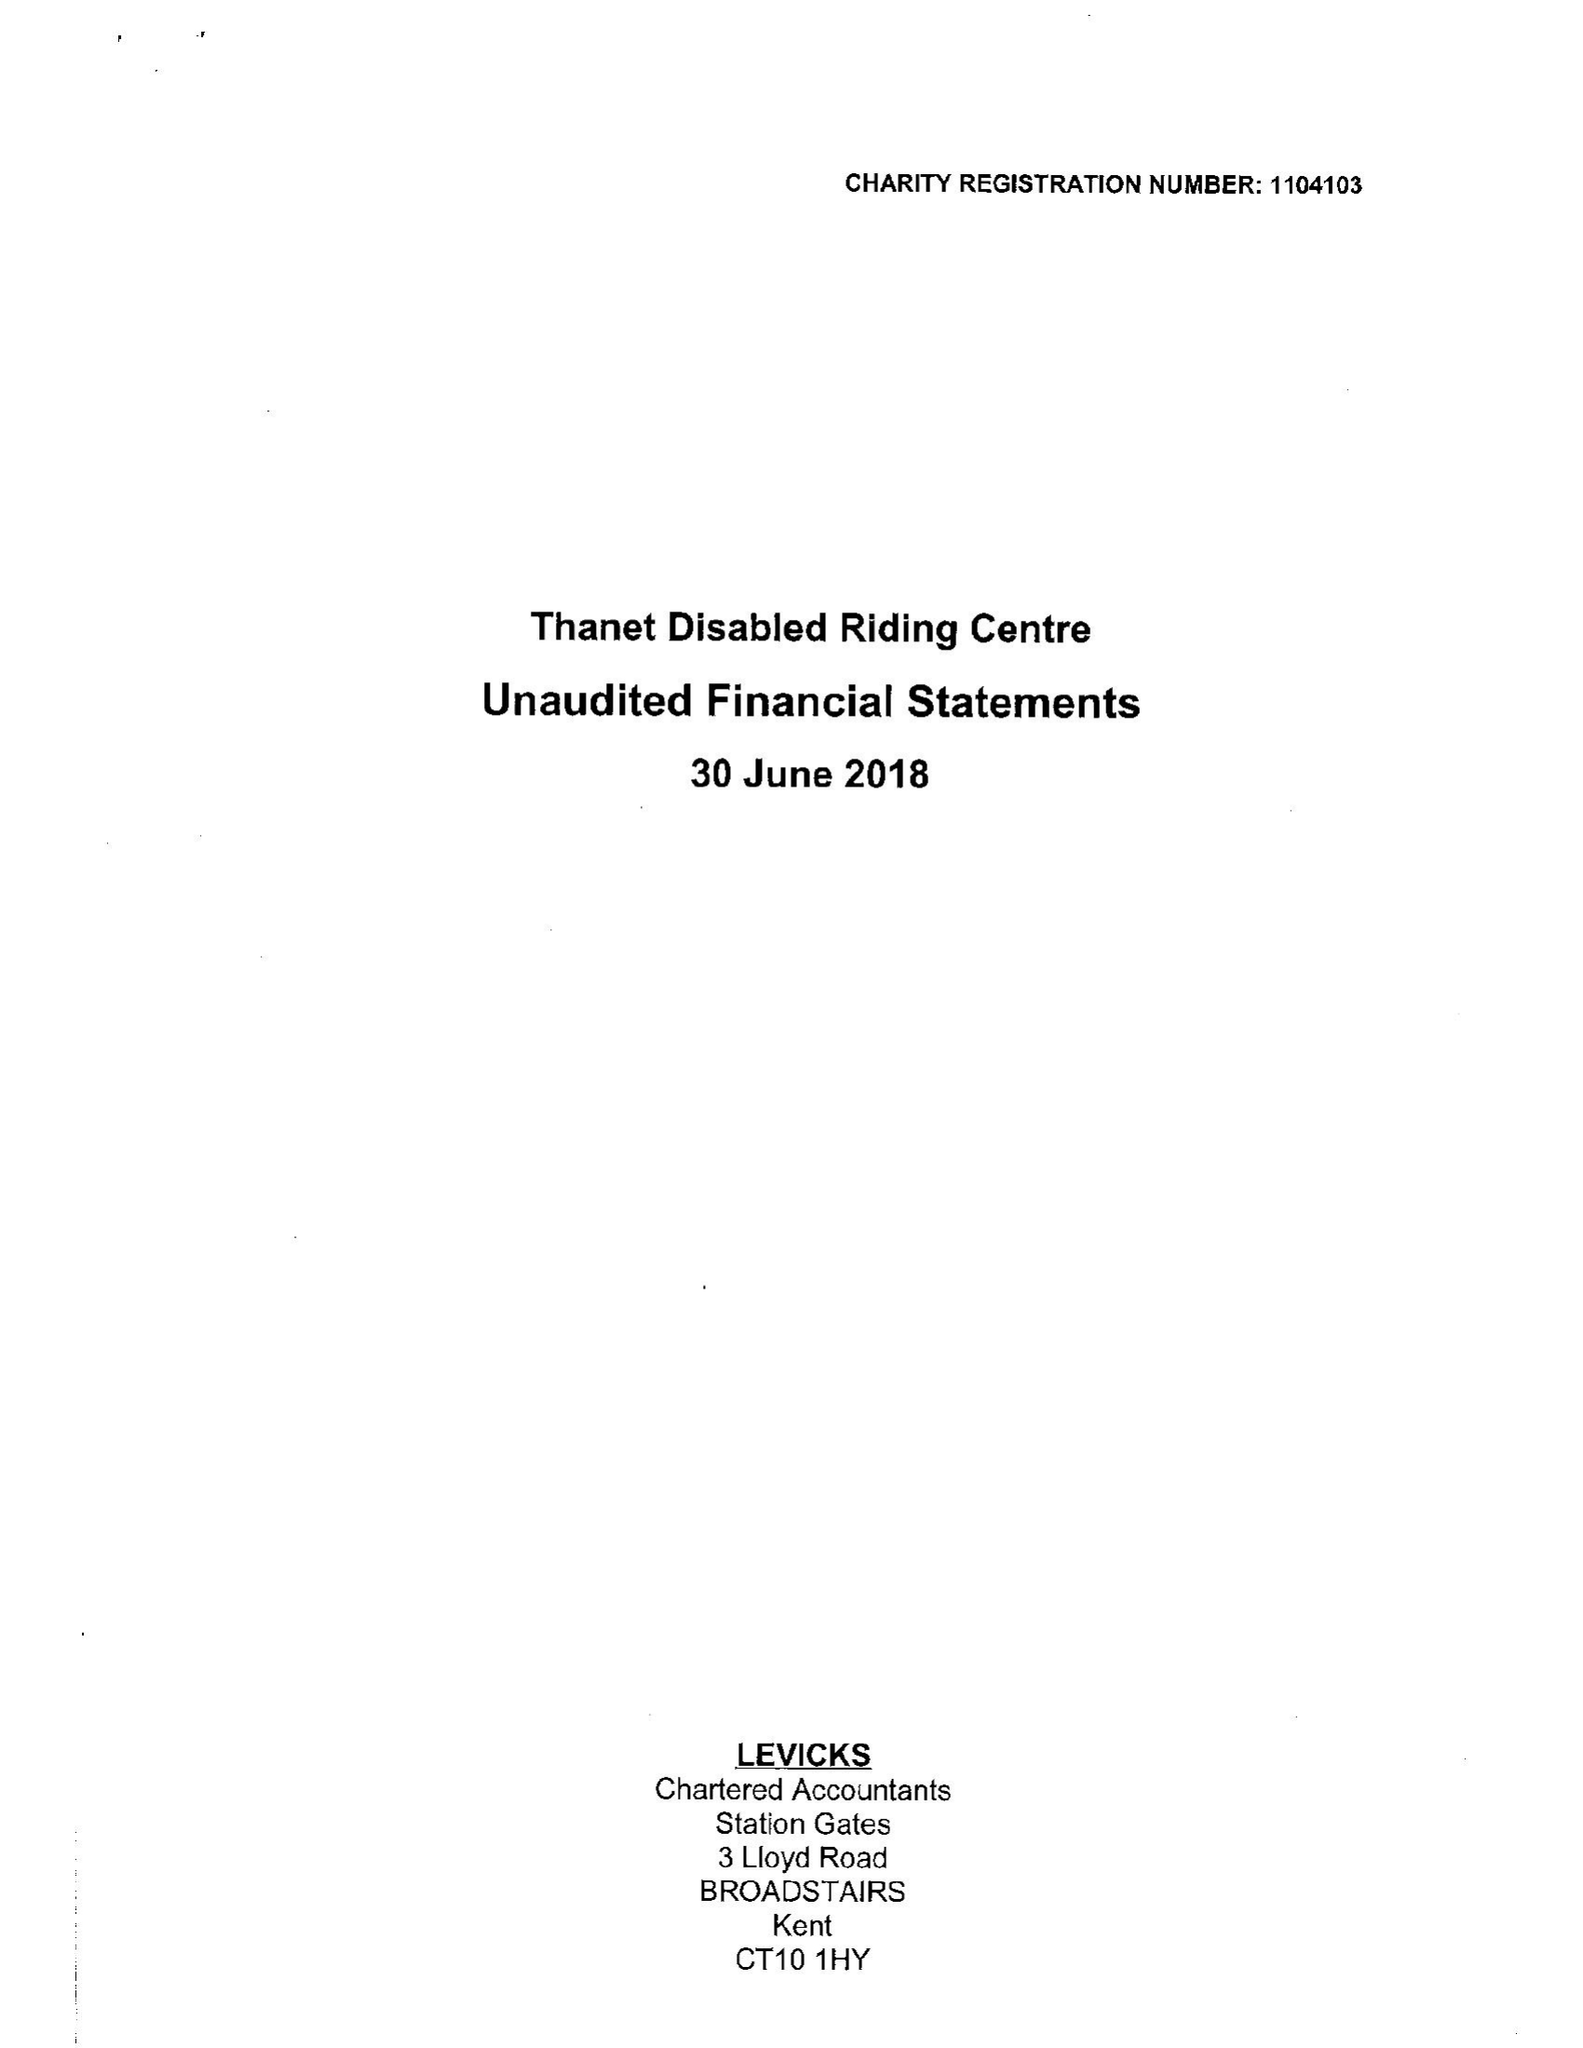What is the value for the spending_annually_in_british_pounds?
Answer the question using a single word or phrase. 45391.00 